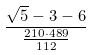Convert formula to latex. <formula><loc_0><loc_0><loc_500><loc_500>\frac { \sqrt { 5 } - 3 - 6 } { \frac { 2 1 0 \cdot 4 8 9 } { 1 1 2 } }</formula> 